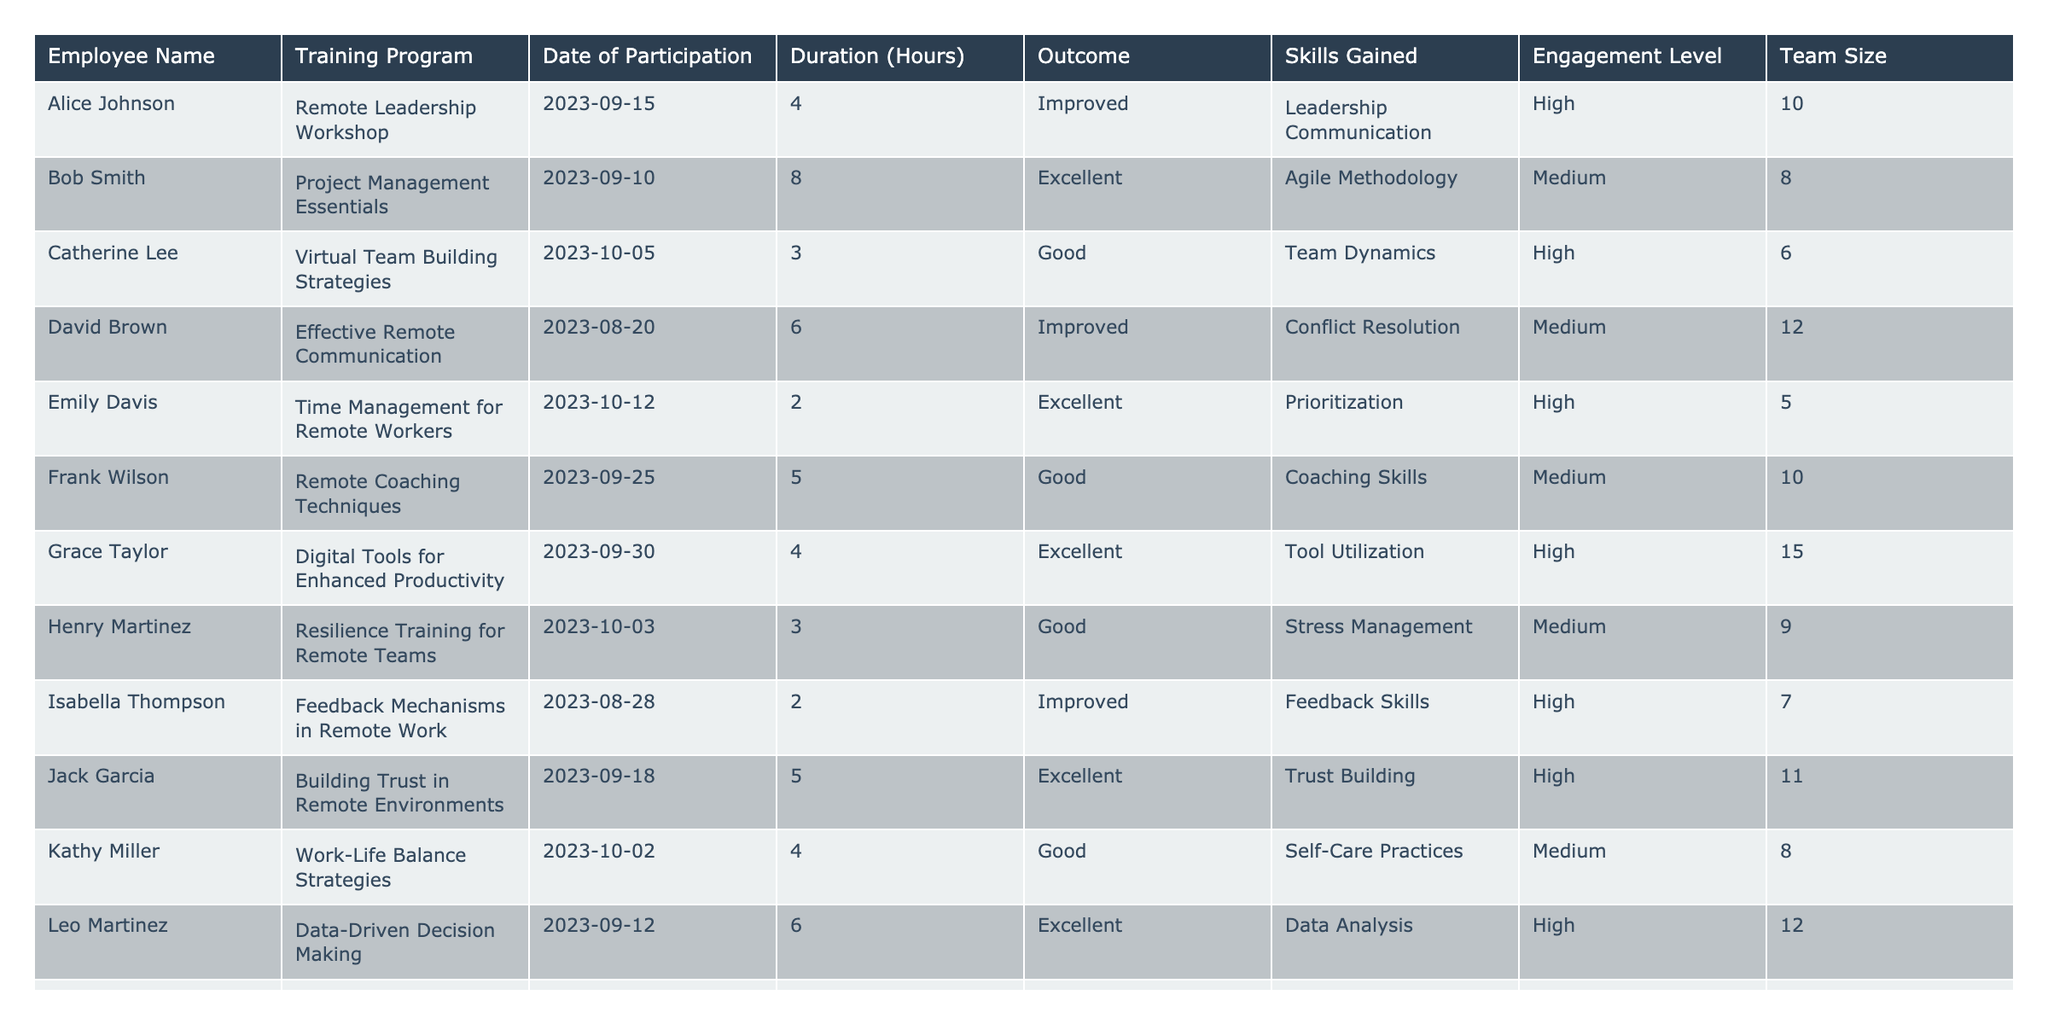What is the outcome of the training program for Emily Davis? The outcome for Emily Davis, who participated in the "Time Management for Remote Workers" training program, is listed as "Excellent."
Answer: Excellent Which training program had the shortest duration? The training program with the shortest duration is "Time Management for Remote Workers," which lasted 2 hours.
Answer: 2 hours How many employees participated in training programs with a high engagement level? Counting the entries in the table, there are a total of 6 employees who had a high engagement level.
Answer: 6 What skills did Grace Taylor gain from her training program? The skills gained by Grace Taylor from the "Digital Tools for Enhanced Productivity" program are listed as "Tool Utilization."
Answer: Tool Utilization What is the average duration of the training programs participated in by the employees? To find the average duration, we sum the durations (4 + 8 + 3 + 6 + 2 + 5 + 4 + 3 + 2 + 5 + 4 + 6 + 2 + 3 + 7 = 57 hours) and divide by the number of programs (15). The average is 57/15 = 3.8 hours.
Answer: 3.8 hours Which training program had the highest number of participants based on the table? Each training program can only be counted once for participation, and since each employee's entry is unique, there is no single training program with multiple participants indicated here.
Answer: None Was the outcome of the "Remote Coaching Techniques" training program good or better? The outcome for the "Remote Coaching Techniques" program is listed as "Good," which means it is not classified as either "Improved" or "Excellent."
Answer: No What was the engagement level for the employee who gained negotiation skills? The employee who gained negotiation skills through the "Conflict Resolution Strategies" training program is Noah White, whose engagement level is noted as "High."
Answer: High How many training programs resulted in an "Excellent" outcome? By checking the table entries, 5 training programs resulted in an "Excellent" outcome: Bob Smith, Emily Davis, Grace Taylor, Jack Garcia, and Olivia Scott.
Answer: 5 What was the engagement level for training programs with outcomes categorized as "Improved"? The engagement levels for the programs with "Improved" outcomes are: Alice Johnson (High), David Brown (Medium), Isabella Thompson (High), and Mia Robinson (Medium). Both High and Medium levels are present, so the answer includes both engagement levels.
Answer: High and Medium Which employee recorded the highest engagement level? Grace Taylor has the highest engagement level listed in the table, which is "High," and is coupled with the highest team size of 15.
Answer: High 